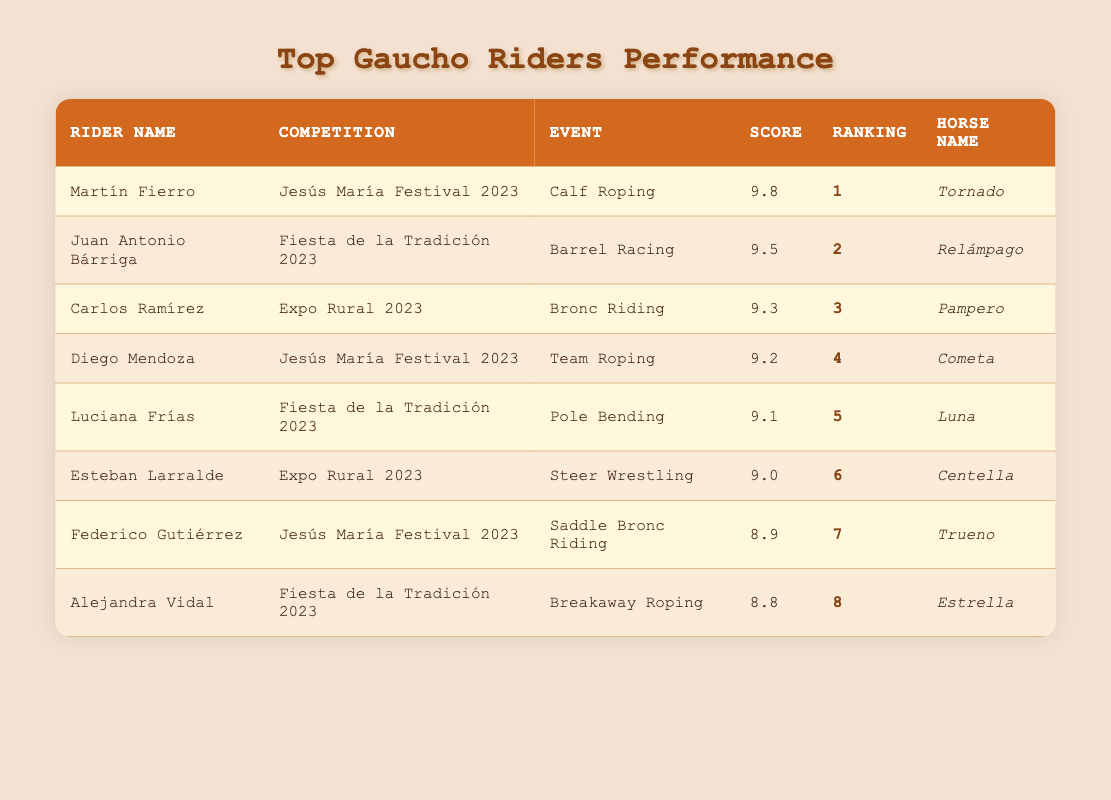What was the highest score achieved in the competitions? The highest score in the table is 9.8, achieved by Martín Fierro in the Calf Roping event at the Jesús María Festival 2023.
Answer: 9.8 Which rider competed in the Barrel Racing event and what was their score? Juan Antonio Bárriga participated in the Barrel Racing event, and he scored 9.5 in the Fiesta de la Tradición 2023.
Answer: 9.5 Did any rider score below 9 in these competitions? No, all the riders listed in the table scored 8.8 or higher, with the lowest score being 8.8 by Alejandra Vidal.
Answer: No What is the average score of the top three riders? To calculate the average, sum the scores of the top three riders: 9.8 + 9.5 + 9.3 = 28.6, then divide by 3, resulting in an average score of 28.6 / 3 = 9.53.
Answer: 9.53 Which event had the lowest scoring rider and what was their score? The event with the lowest scoring rider is Breakaway Roping, where Alejandra Vidal scored 8.8 in the Fiesta de la Tradición 2023.
Answer: 8.8 How many riders scored higher than 9.0? Five riders scored higher than 9.0: Martín Fierro, Juan Antonio Bárriga, Carlos Ramírez, Diego Mendoza, and Luciana Frías.
Answer: 5 Were there any riders who competed in the Jesús María Festival 2023 and what events did they participate in? Yes, there were three riders at the Jesús María Festival 2023: Martín Fierro in Calf Roping, Diego Mendoza in Team Roping, and Federico Gutiérrez in Saddle Bronc Riding.
Answer: Yes What is the difference in scores between the first-ranked and the second-ranked riders? The difference between the scores of the first-ranked rider (Martín Fierro with 9.8) and the second-ranked rider (Juan Antonio Bárriga with 9.5) is calculated by subtracting: 9.8 - 9.5 = 0.3.
Answer: 0.3 